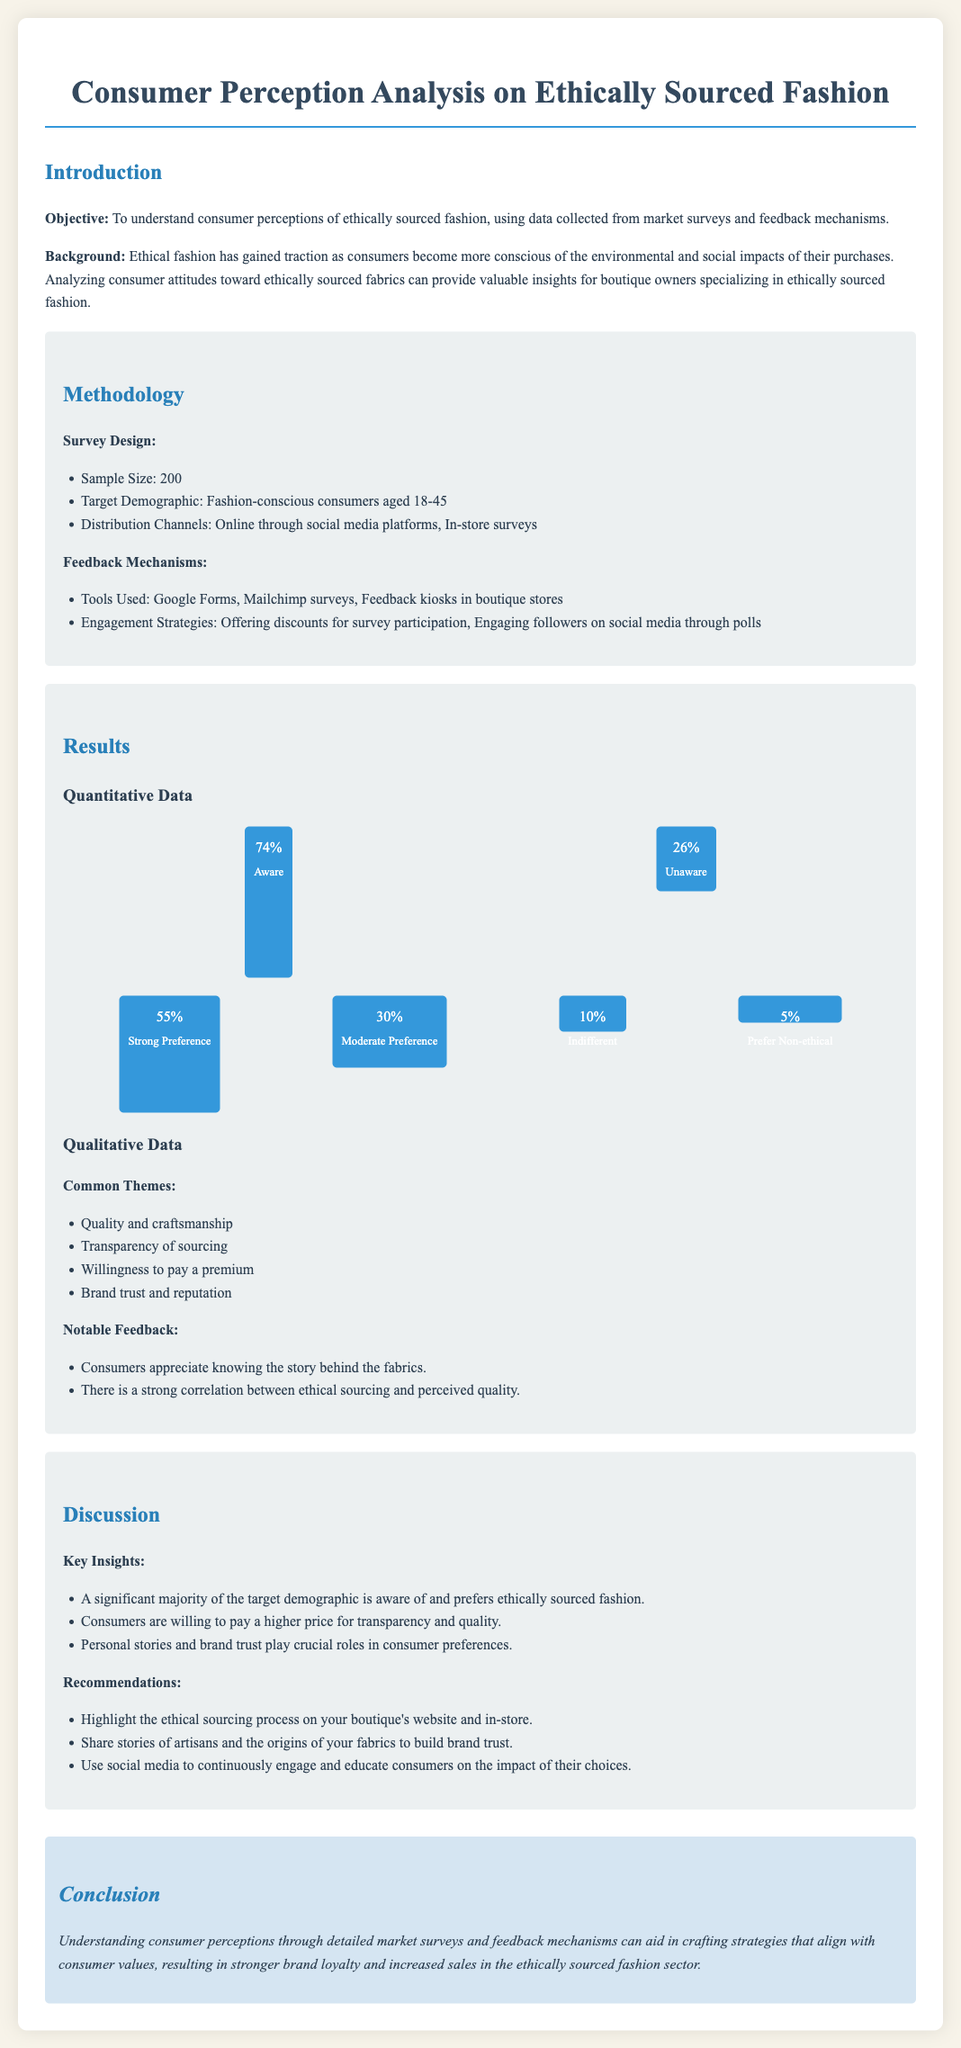what was the sample size of the survey? The sample size is stated in the methodology section, which specifies a sample size of 200.
Answer: 200 what percentage of respondents were aware of ethically sourced fashion? The result section indicates that 74% of respondents were aware.
Answer: 74% what is the strongest preference percentage for ethically sourced fashion? The quantitative data shows that 55% have a strong preference for ethically sourced fashion.
Answer: 55% what are two common themes identified in the qualitative data? Common themes are listed in the results section, which include quality and craftsmanship, and transparency of sourcing.
Answer: Quality and craftsmanship; transparency of sourcing what is one key insight from the discussion section? The discussion section outlines that a significant majority of the target demographic is aware of and prefers ethically sourced fashion.
Answer: A significant majority is aware and prefers ethically sourced fashion what tool was used for feedback mechanisms? The methodology section lists tools including Google Forms and Mailchimp surveys.
Answer: Google Forms what is a noted willingness among consumers related to ethical sourcing? Respondents are stated to be willing to pay a premium for transparency and quality in the discussion section.
Answer: Willingness to pay a premium how many respondents expressed indifference towards ethical sourcing? The results section provides that 10% of respondents were indifferent.
Answer: 10% 